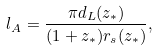Convert formula to latex. <formula><loc_0><loc_0><loc_500><loc_500>l _ { A } = \frac { \pi d _ { L } ( z _ { * } ) } { ( 1 + z _ { * } ) r _ { s } ( z _ { * } ) } ,</formula> 